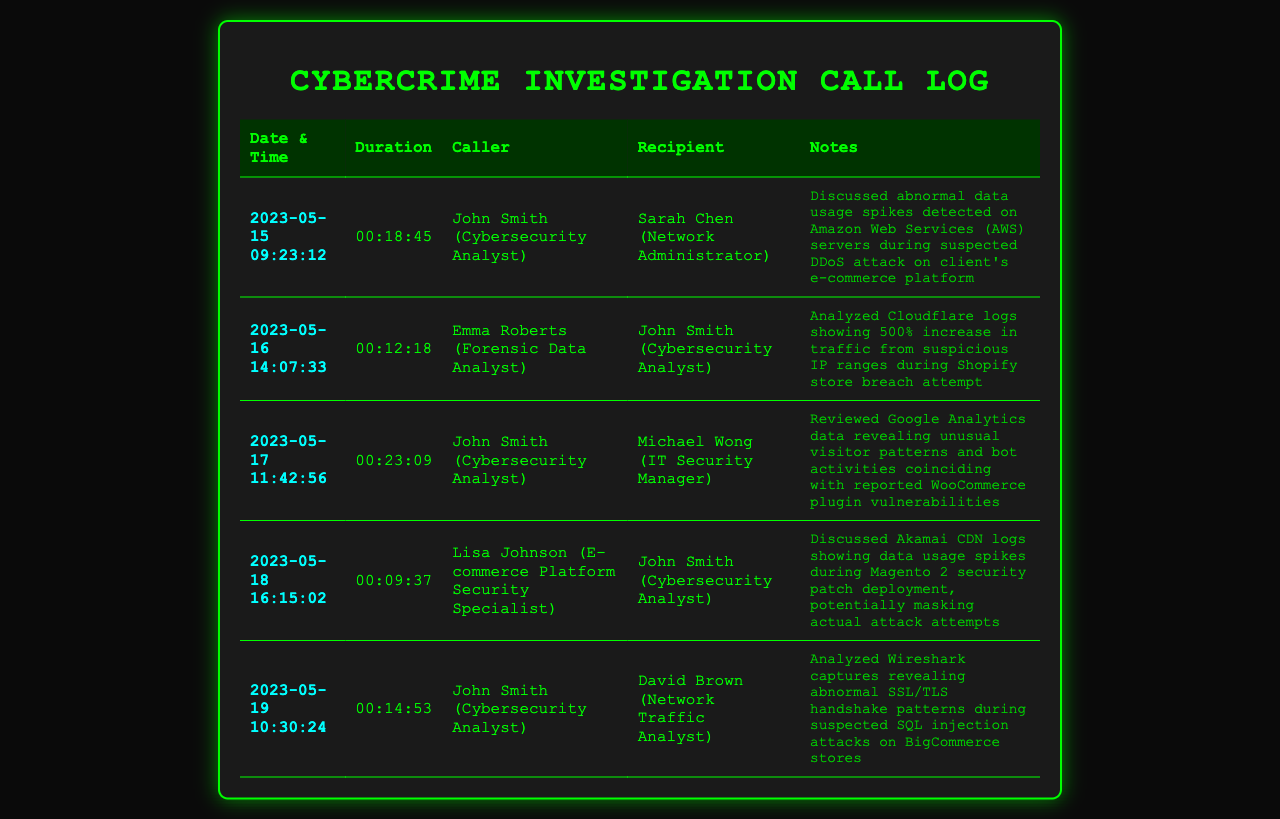what was discussed on 2023-05-15? The discussion on this date was about abnormal data usage spikes detected on Amazon Web Services servers during a suspected DDoS attack on a client's e-commerce platform.
Answer: abnormal data usage spikes during suspected DDoS attack who was the recipient of the call on 2023-05-16? The recipient of the call on this date was John Smith, the Cybersecurity Analyst.
Answer: John Smith what type of attack was analyzed on 2023-05-19? The analysis on this date focused on suspected SQL injection attacks on BigCommerce stores.
Answer: SQL injection attacks how long was the call between John Smith and Michael Wong? The call duration between John Smith and Michael Wong was 23 minutes and 9 seconds.
Answer: 00:23:09 what was the increase in traffic during the Shopify store breach attempt? The increase in traffic analyzed during this event was reported as 500%.
Answer: 500% what logs were reviewed on 2023-05-17? The logs reviewed on this date were Google Analytics data revealing unusual visitor patterns and bot activities.
Answer: Google Analytics data who initiated the call on 2023-05-18? The call on this date was initiated by Lisa Johnson, the E-commerce Platform Security Specialist.
Answer: Lisa Johnson what was discussed related to Akamai logs on 2023-05-18? The discussion involved data usage spikes during Magento 2 security patch deployment, potentially masking actual attack attempts.
Answer: data usage spikes during Magento 2 security patch deployment 